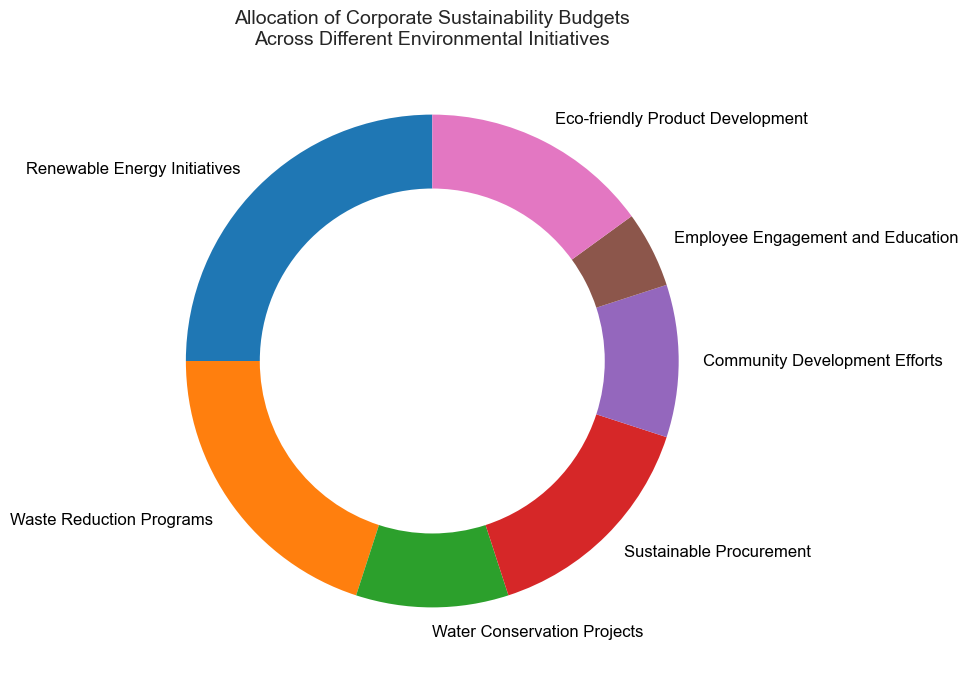What percent of the budget is allocated to eco-friendly product development? Look for the allocation percentage labeled "Eco-friendly Product Development" on the ring chart.
Answer: 15% How does the allocation for renewable energy initiatives compare to waste reduction programs? Examine the labels and corresponding percentages for both "Renewable Energy Initiatives" and "Waste Reduction Programs" on the ring chart. Renewable Energy Initiatives have a 25% allocation, while Waste Reduction Programs have a 20% allocation.
Answer: Renewable Energy Initiatives have a higher allocation Which initiative has the smallest budget allocation? Identify the initiative with the smallest percentage allocation by comparing all the segments in the ring chart.
Answer: Employee Engagement and Education What is the combined percentage allocation for sustainable procurement and community development efforts? Find the percentage allocations for "Sustainable Procurement" and "Community Development Efforts" and sum them up (15% + 10%).
Answer: 25% Among renewable energy initiatives, waste reduction programs, and eco-friendly product development, which two initiatives together have the highest combined allocation? Compare the combined percentages of the initiatives:
- Renewable Energy Initiatives + Waste Reduction Programs = 25% + 20% = 45%
- Renewable Energy Initiatives + Eco-friendly Product Development = 25% + 15% = 40%
- Waste Reduction Programs + Eco-friendly Product Development = 20% + 15% = 35%
The highest combined allocation is from Renewable Energy Initiatives + Waste Reduction Programs.
Answer: Renewable Energy Initiatives and Waste Reduction Programs Does the total allocation for water conservation projects and community development efforts exceed the allocation for waste reduction programs? Compare the sum of the percentages for "Water Conservation Projects" and "Community Development Efforts" (10% + 10%) with the percentage for "Waste Reduction Programs" (20%).
Answer: No Which three initiatives have the lowest budget allocations? Identify the three initiatives with the smallest percentages by comparing all the segments in the ring chart. The initiatives are "Water Conservation Projects" (10%), "Community Development Efforts" (10%), and "Employee Engagement and Education" (5%).
Answer: Water Conservation Projects, Community Development Efforts, Employee Engagement and Education Between waste reduction programs and sustainable procurement, which initiative has a greater budget allocation, and by how much? Compare the percentage allocations for "Waste Reduction Programs" (20%) and "Sustainable Procurement" (15%). Calculate the difference (20% - 15% = 5%).
Answer: Waste Reduction Programs by 5% What is the total percentage allocation for all initiatives related to product development and procurement? Sum the percentages of "Sustainable Procurement" (15%) and "Eco-friendly Product Development" (15%) (15% + 15%).
Answer: 30% Is the budget allocation for renewable energy initiatives more than double that of employee engagement and education? Compare the budget allocation for "Renewable Energy Initiatives" (25%) to twice the allocation for "Employee Engagement and Education" (2 * 5% = 10%).
Answer: Yes 